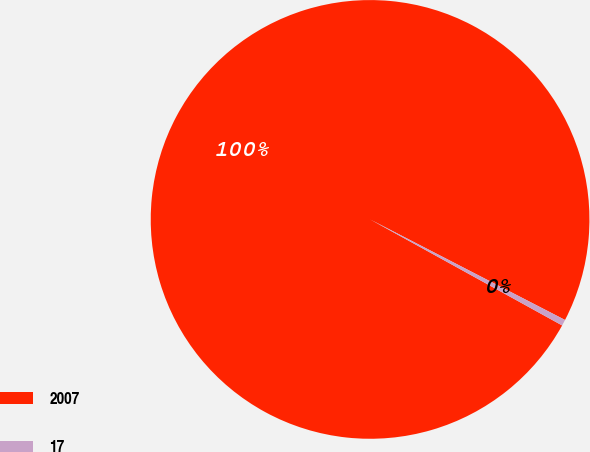Convert chart. <chart><loc_0><loc_0><loc_500><loc_500><pie_chart><fcel>2007<fcel>17<nl><fcel>99.55%<fcel>0.45%<nl></chart> 